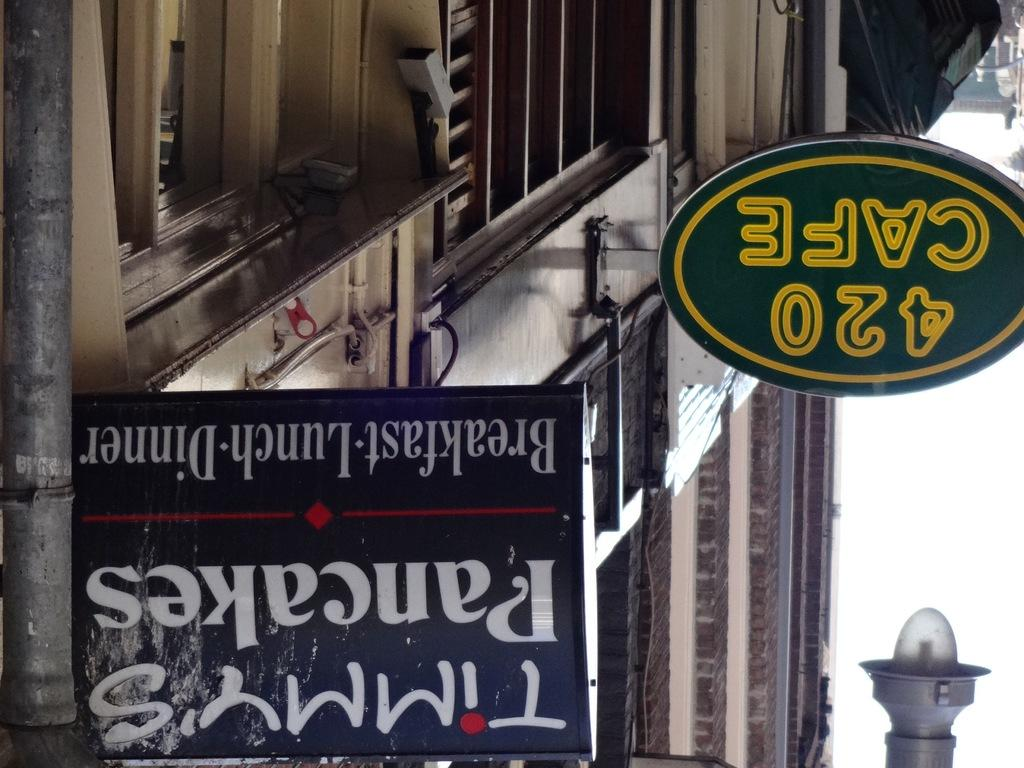What type of structure is visible in the image? There is a building in the image. What is attached to the building? Boards with text are attached to the building. Can you describe any other objects in the image? There is a lamp in the image. How many eyes can be seen on the building in the image? There are no eyes visible on the building in the image. 